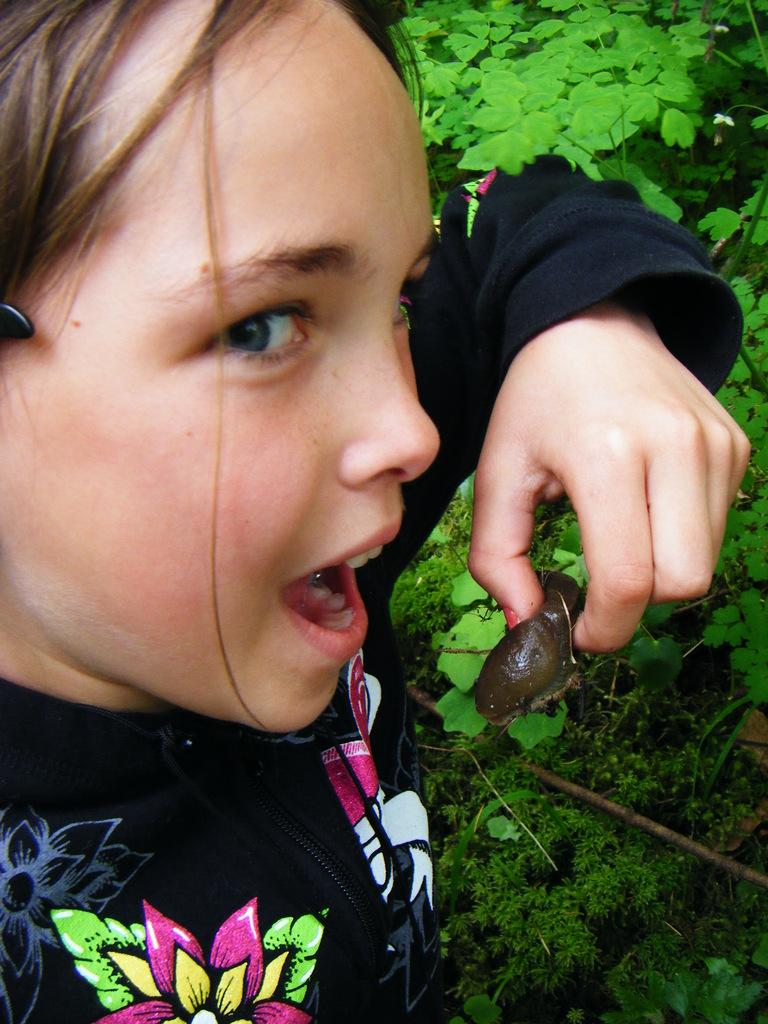Who is the main subject in the foreground of the image? There is a girl in the foreground of the image. What is the girl holding in her hand? The girl is holding a snail in her hand. What is the girl's facial expression in the image? The girl's mouth is open. What can be seen in the background of the image? There are trees and plants in the background of the image. What type of error can be seen in the image? There is no error present in the image. Is the girl wearing a scarf in the image? The image does not show the girl wearing a scarf. Can you see a goose in the image? There is no goose present in the image. 